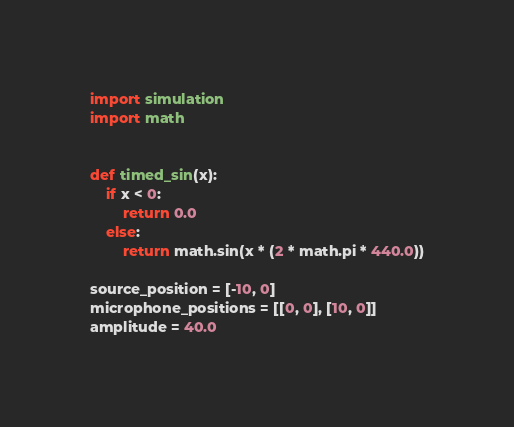Convert code to text. <code><loc_0><loc_0><loc_500><loc_500><_Python_>import simulation
import math


def timed_sin(x):
    if x < 0:
        return 0.0
    else: 
        return math.sin(x * (2 * math.pi * 440.0))

source_position = [-10, 0]
microphone_positions = [[0, 0], [10, 0]]
amplitude = 40.0</code> 